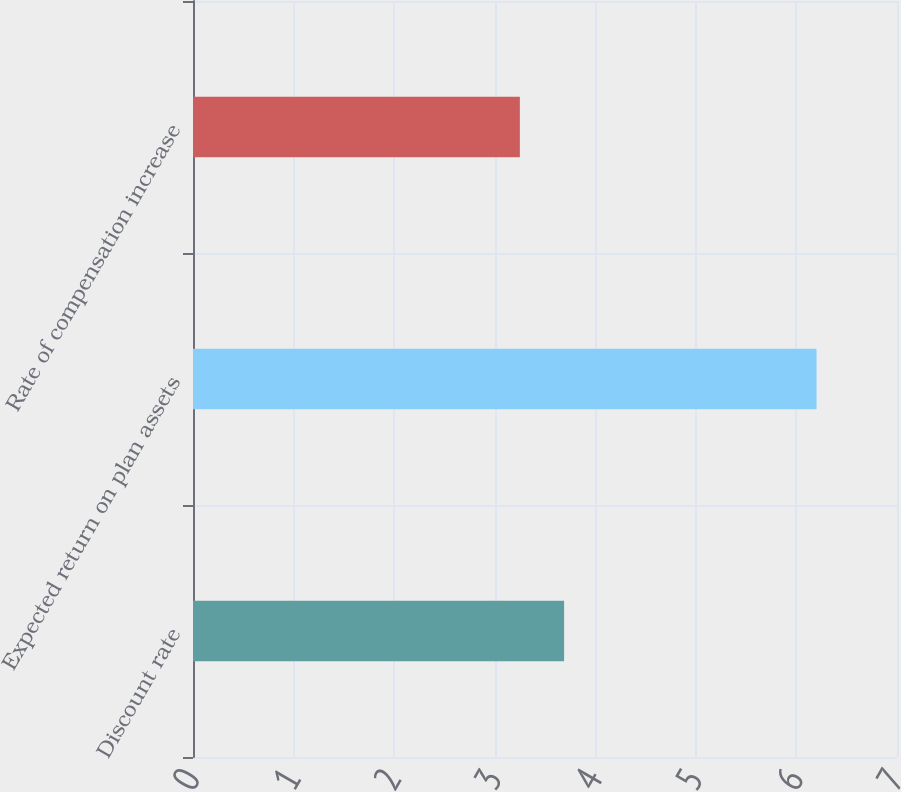<chart> <loc_0><loc_0><loc_500><loc_500><bar_chart><fcel>Discount rate<fcel>Expected return on plan assets<fcel>Rate of compensation increase<nl><fcel>3.69<fcel>6.2<fcel>3.25<nl></chart> 